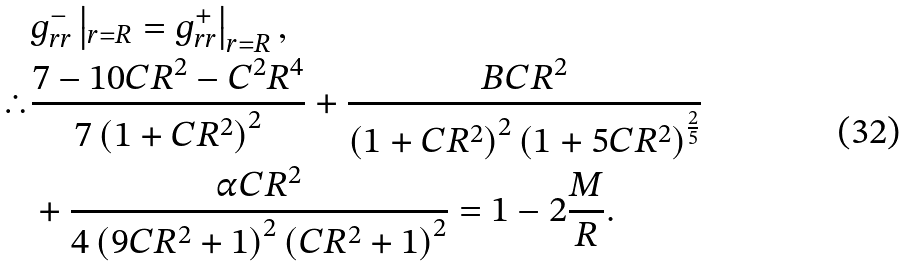Convert formula to latex. <formula><loc_0><loc_0><loc_500><loc_500>& g ^ { - } _ { r r } \left | _ { r = R } = g ^ { + } _ { r r } \right | _ { r = R } , \\ \therefore & \frac { 7 - 1 0 C R ^ { 2 } - C ^ { 2 } R ^ { 4 } } { 7 \left ( 1 + C R ^ { 2 } \right ) ^ { 2 } } + \frac { B C R ^ { 2 } } { \left ( 1 + C R ^ { 2 } \right ) ^ { 2 } \left ( 1 + 5 C R ^ { 2 } \right ) ^ { \frac { 2 } { 5 } } } \\ & + \frac { \alpha C R ^ { 2 } } { 4 \left ( 9 C R ^ { 2 } + 1 \right ) ^ { 2 } \left ( C R ^ { 2 } + 1 \right ) ^ { 2 } } = 1 - 2 \frac { M } { R } .</formula> 